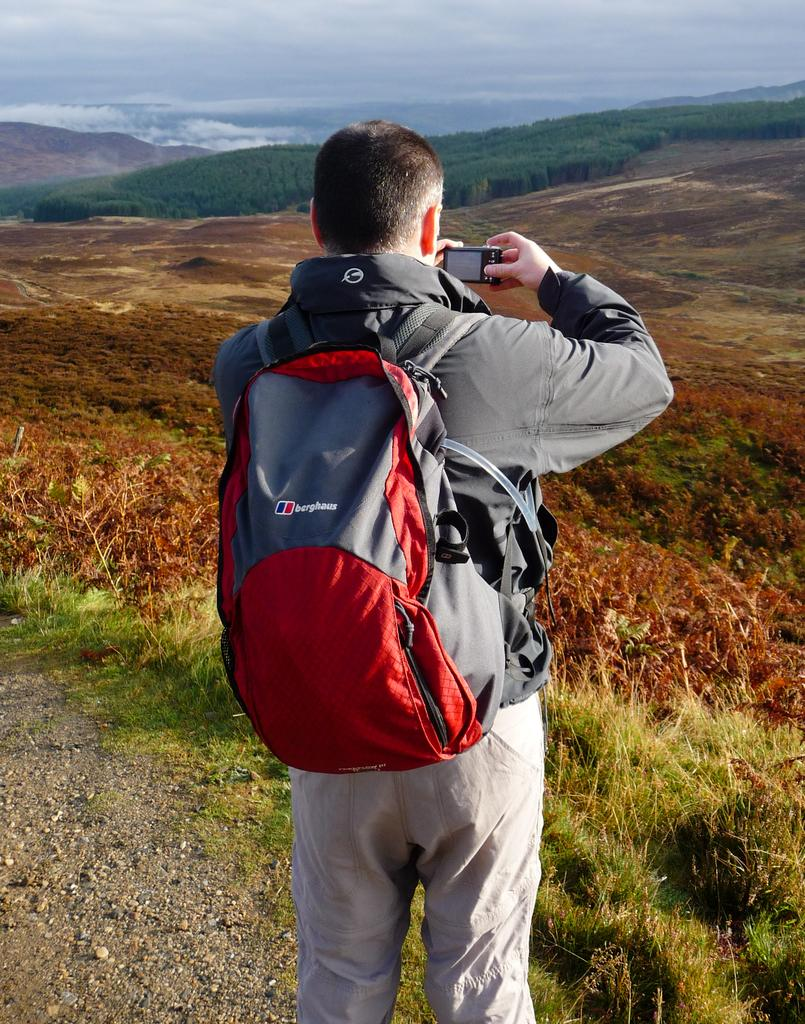<image>
Share a concise interpretation of the image provided. A man taking a picture of the scenery is wearing a Berghaus backpack. 